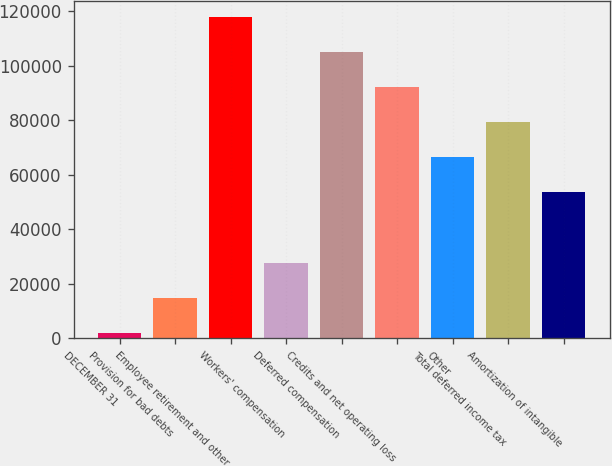<chart> <loc_0><loc_0><loc_500><loc_500><bar_chart><fcel>DECEMBER 31<fcel>Provision for bad debts<fcel>Employee retirement and other<fcel>Workers' compensation<fcel>Deferred compensation<fcel>Credits and net operating loss<fcel>Other<fcel>Total deferred income tax<fcel>Amortization of intangible<nl><fcel>2007<fcel>14885.9<fcel>117917<fcel>27764.8<fcel>105038<fcel>92159.3<fcel>66401.5<fcel>79280.4<fcel>53522.6<nl></chart> 